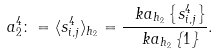<formula> <loc_0><loc_0><loc_500><loc_500>a _ { 2 } ^ { 4 } \colon = \langle s ^ { 4 } _ { i , j } \rangle _ { h _ { 2 } } = \frac { \ k a _ { h _ { 2 } } \left \{ s ^ { 4 } _ { i , j } \right \} } { \ k a _ { h _ { 2 } } \left \{ 1 \right \} } .</formula> 